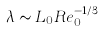Convert formula to latex. <formula><loc_0><loc_0><loc_500><loc_500>\lambda \sim L _ { 0 } R e _ { 0 } ^ { - 1 / 3 }</formula> 